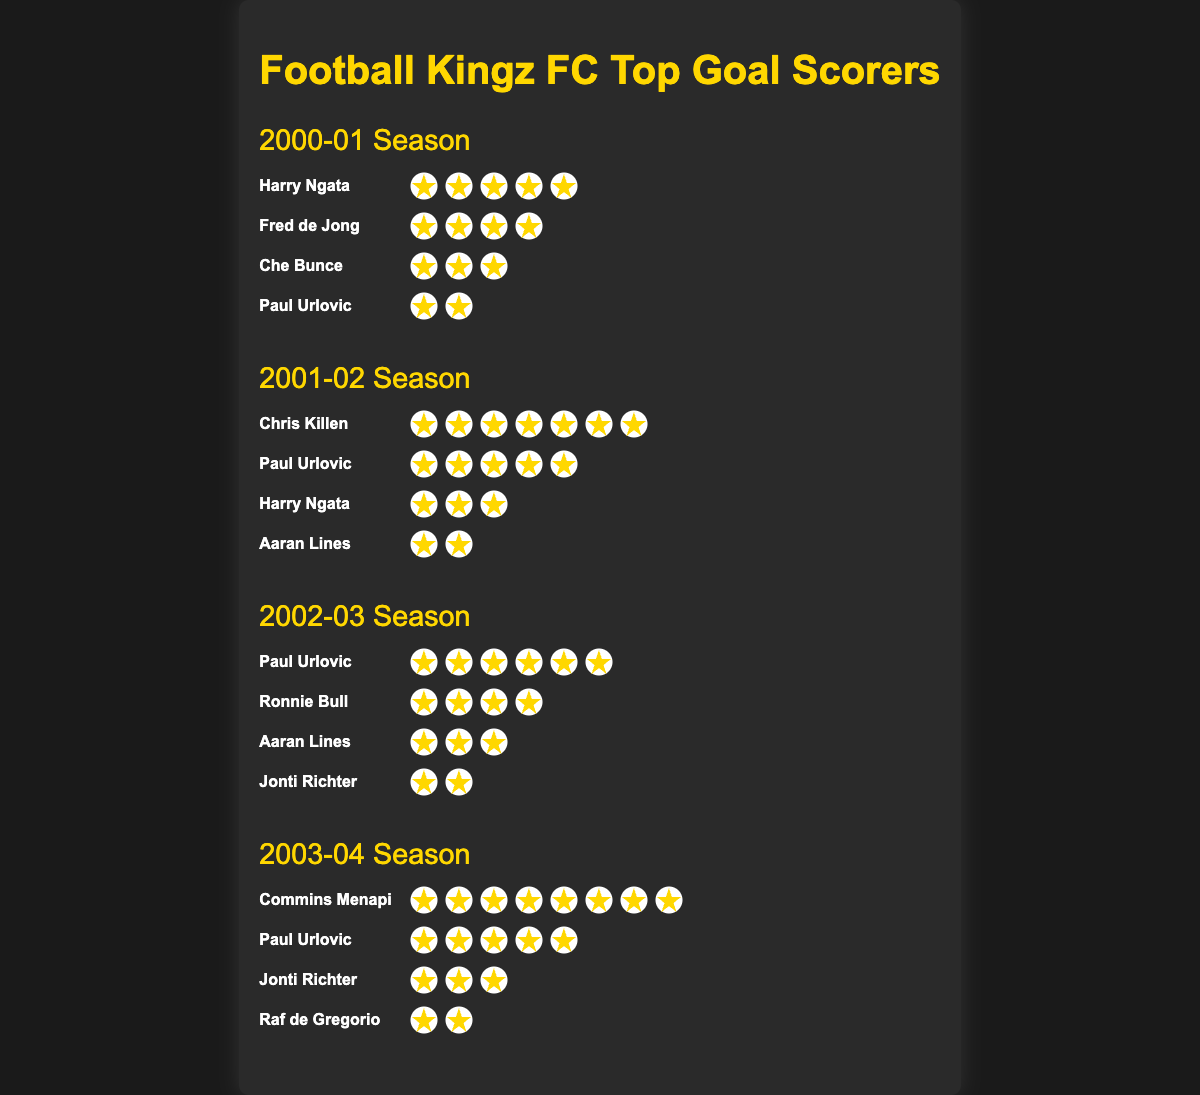Which player scored the most goals in the 2001-02 season? Look at the goal icons for the 2001-02 season. Chris Killen has the most icons with 7 goals.
Answer: Chris Killen Who was the top scorer in the 2003-04 season? Observe the 2003-04 season's section and count the goal icons. Commins Menapi leads with 8 goals.
Answer: Commins Menapi How many total goals did Paul Urlovic score over all the seasons? Sum up Paul Urlovic's goals from each season: 2 (2000-01) + 5 (2001-02) + 6 (2002-03) + 5 (2003-04) = 18 goals.
Answer: 18 Compare the goals scored by Harry Ngata in the 2000-01 and 2001-02 seasons. Which season did he score more? Count the goal icons for Harry Ngata in both seasons. 5 goals in 2000-01 vs. 3 goals in 2001-02. He scored more in 2000-01.
Answer: 2000-01 What is the average number of goals scored by the top scorers of each season? Find the top scorer in each season (5, 7, 6, 8 goals), then compute the average: (5 + 7 + 6 + 8) / 4 = 6.5 goals.
Answer: 6.5 Which season had the highest total number of goals scored by the top four players? Add up the goals of the top four players in each season: 5+4+3+2=14 (2000-01), 7+5+3+2=17 (2001-02), 6+4+3+2=15 (2002-03), 8+5+3+2=18 (2003-04). The 2003-04 season has the most with 18 goals.
Answer: 2003-04 In which season did Paul Urlovic score the most goals? Check the number of goals in each season for Paul Urlovic and identify the highest: 2 (2000-01), 5 (2001-02), 6 (2002-03), 5 (2003-04). The most goals were scored in 2002-03.
Answer: 2002-03 Who scored goals in all the listed seasons? Look for players who appear in each season. Only Paul Urlovic appears in all the seasons.
Answer: Paul Urlovic Count the total number of goals scored by all players in the 2000-01 season. Add the goals of each player in the 2000-01 season: 5+4+3+2 = 14 goals.
Answer: 14 